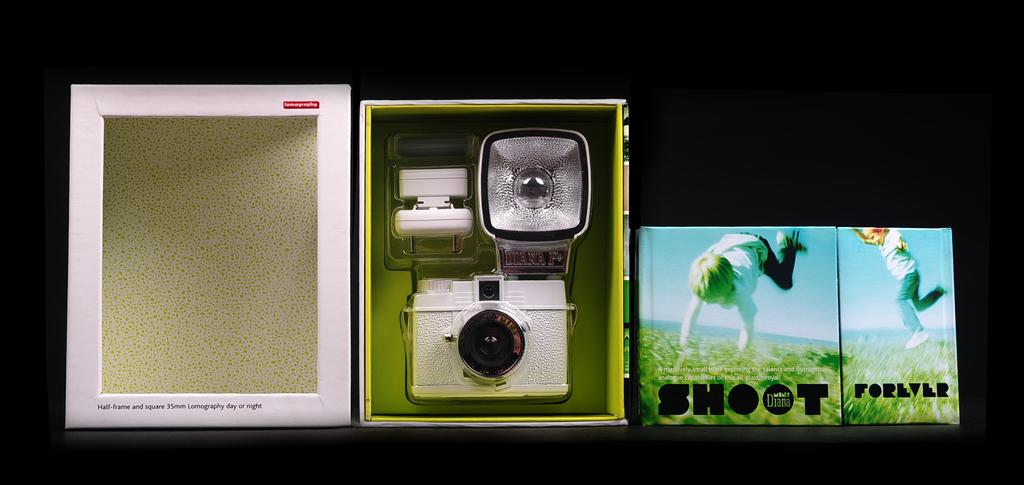What object is the main focus of the image? There is a box in the image. What is inside the box? A camera is placed inside the box. What can be seen in the images visible in the image? There are images of a boy playing visible in the image. What additional information is provided in the image? There is text present in the image. How does the moon expand in the image? The moon is not present in the image, so it cannot expand. What type of pipe is visible in the image? There is no pipe visible in the image. 